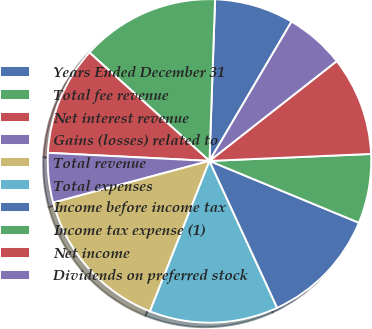Convert chart to OTSL. <chart><loc_0><loc_0><loc_500><loc_500><pie_chart><fcel>Years Ended December 31<fcel>Total fee revenue<fcel>Net interest revenue<fcel>Gains (losses) related to<fcel>Total revenue<fcel>Total expenses<fcel>Income before income tax<fcel>Income tax expense (1)<fcel>Net income<fcel>Dividends on preferred stock<nl><fcel>7.92%<fcel>13.86%<fcel>10.89%<fcel>4.95%<fcel>14.85%<fcel>12.87%<fcel>11.88%<fcel>6.93%<fcel>9.9%<fcel>5.94%<nl></chart> 